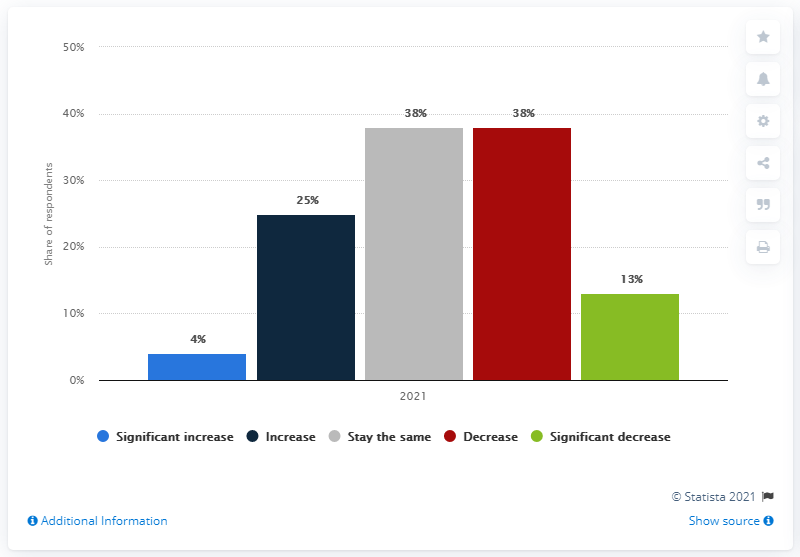Give some essential details in this illustration. In 2021, American countries invested in European real estate markets. 